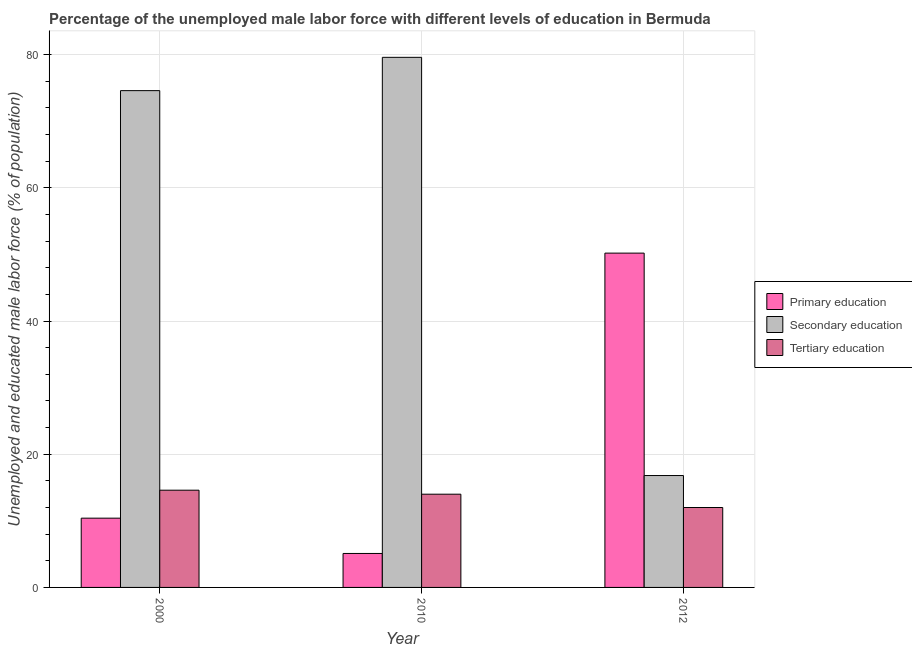How many bars are there on the 2nd tick from the left?
Offer a terse response. 3. What is the label of the 2nd group of bars from the left?
Keep it short and to the point. 2010. In how many cases, is the number of bars for a given year not equal to the number of legend labels?
Your answer should be compact. 0. What is the percentage of male labor force who received tertiary education in 2012?
Your answer should be compact. 12. Across all years, what is the maximum percentage of male labor force who received secondary education?
Give a very brief answer. 79.6. Across all years, what is the minimum percentage of male labor force who received primary education?
Keep it short and to the point. 5.1. In which year was the percentage of male labor force who received primary education maximum?
Offer a terse response. 2012. In which year was the percentage of male labor force who received primary education minimum?
Ensure brevity in your answer.  2010. What is the total percentage of male labor force who received secondary education in the graph?
Your answer should be compact. 171. What is the difference between the percentage of male labor force who received primary education in 2000 and that in 2010?
Give a very brief answer. 5.3. What is the difference between the percentage of male labor force who received secondary education in 2010 and the percentage of male labor force who received tertiary education in 2012?
Provide a succinct answer. 62.8. What is the average percentage of male labor force who received secondary education per year?
Your answer should be compact. 57. In how many years, is the percentage of male labor force who received tertiary education greater than 4 %?
Keep it short and to the point. 3. What is the ratio of the percentage of male labor force who received secondary education in 2000 to that in 2012?
Provide a short and direct response. 4.44. What is the difference between the highest and the second highest percentage of male labor force who received primary education?
Ensure brevity in your answer.  39.8. What is the difference between the highest and the lowest percentage of male labor force who received secondary education?
Your response must be concise. 62.8. What does the 3rd bar from the left in 2000 represents?
Your response must be concise. Tertiary education. Is it the case that in every year, the sum of the percentage of male labor force who received primary education and percentage of male labor force who received secondary education is greater than the percentage of male labor force who received tertiary education?
Give a very brief answer. Yes. How many bars are there?
Ensure brevity in your answer.  9. Are all the bars in the graph horizontal?
Make the answer very short. No. What is the difference between two consecutive major ticks on the Y-axis?
Keep it short and to the point. 20. Does the graph contain grids?
Your answer should be very brief. Yes. Where does the legend appear in the graph?
Offer a very short reply. Center right. How many legend labels are there?
Keep it short and to the point. 3. What is the title of the graph?
Provide a short and direct response. Percentage of the unemployed male labor force with different levels of education in Bermuda. What is the label or title of the Y-axis?
Offer a terse response. Unemployed and educated male labor force (% of population). What is the Unemployed and educated male labor force (% of population) in Primary education in 2000?
Your response must be concise. 10.4. What is the Unemployed and educated male labor force (% of population) of Secondary education in 2000?
Provide a short and direct response. 74.6. What is the Unemployed and educated male labor force (% of population) of Tertiary education in 2000?
Give a very brief answer. 14.6. What is the Unemployed and educated male labor force (% of population) of Primary education in 2010?
Your answer should be very brief. 5.1. What is the Unemployed and educated male labor force (% of population) in Secondary education in 2010?
Provide a short and direct response. 79.6. What is the Unemployed and educated male labor force (% of population) in Tertiary education in 2010?
Ensure brevity in your answer.  14. What is the Unemployed and educated male labor force (% of population) in Primary education in 2012?
Offer a very short reply. 50.2. What is the Unemployed and educated male labor force (% of population) in Secondary education in 2012?
Make the answer very short. 16.8. What is the Unemployed and educated male labor force (% of population) in Tertiary education in 2012?
Your answer should be very brief. 12. Across all years, what is the maximum Unemployed and educated male labor force (% of population) in Primary education?
Your answer should be very brief. 50.2. Across all years, what is the maximum Unemployed and educated male labor force (% of population) in Secondary education?
Provide a short and direct response. 79.6. Across all years, what is the maximum Unemployed and educated male labor force (% of population) of Tertiary education?
Your answer should be compact. 14.6. Across all years, what is the minimum Unemployed and educated male labor force (% of population) of Primary education?
Ensure brevity in your answer.  5.1. Across all years, what is the minimum Unemployed and educated male labor force (% of population) of Secondary education?
Your answer should be compact. 16.8. What is the total Unemployed and educated male labor force (% of population) in Primary education in the graph?
Make the answer very short. 65.7. What is the total Unemployed and educated male labor force (% of population) of Secondary education in the graph?
Give a very brief answer. 171. What is the total Unemployed and educated male labor force (% of population) of Tertiary education in the graph?
Your answer should be very brief. 40.6. What is the difference between the Unemployed and educated male labor force (% of population) in Secondary education in 2000 and that in 2010?
Make the answer very short. -5. What is the difference between the Unemployed and educated male labor force (% of population) in Primary education in 2000 and that in 2012?
Make the answer very short. -39.8. What is the difference between the Unemployed and educated male labor force (% of population) of Secondary education in 2000 and that in 2012?
Ensure brevity in your answer.  57.8. What is the difference between the Unemployed and educated male labor force (% of population) of Tertiary education in 2000 and that in 2012?
Provide a succinct answer. 2.6. What is the difference between the Unemployed and educated male labor force (% of population) in Primary education in 2010 and that in 2012?
Give a very brief answer. -45.1. What is the difference between the Unemployed and educated male labor force (% of population) of Secondary education in 2010 and that in 2012?
Your answer should be compact. 62.8. What is the difference between the Unemployed and educated male labor force (% of population) in Primary education in 2000 and the Unemployed and educated male labor force (% of population) in Secondary education in 2010?
Keep it short and to the point. -69.2. What is the difference between the Unemployed and educated male labor force (% of population) in Primary education in 2000 and the Unemployed and educated male labor force (% of population) in Tertiary education in 2010?
Ensure brevity in your answer.  -3.6. What is the difference between the Unemployed and educated male labor force (% of population) in Secondary education in 2000 and the Unemployed and educated male labor force (% of population) in Tertiary education in 2010?
Offer a terse response. 60.6. What is the difference between the Unemployed and educated male labor force (% of population) of Primary education in 2000 and the Unemployed and educated male labor force (% of population) of Secondary education in 2012?
Offer a terse response. -6.4. What is the difference between the Unemployed and educated male labor force (% of population) in Secondary education in 2000 and the Unemployed and educated male labor force (% of population) in Tertiary education in 2012?
Your answer should be compact. 62.6. What is the difference between the Unemployed and educated male labor force (% of population) in Primary education in 2010 and the Unemployed and educated male labor force (% of population) in Secondary education in 2012?
Your answer should be very brief. -11.7. What is the difference between the Unemployed and educated male labor force (% of population) in Primary education in 2010 and the Unemployed and educated male labor force (% of population) in Tertiary education in 2012?
Your response must be concise. -6.9. What is the difference between the Unemployed and educated male labor force (% of population) of Secondary education in 2010 and the Unemployed and educated male labor force (% of population) of Tertiary education in 2012?
Offer a terse response. 67.6. What is the average Unemployed and educated male labor force (% of population) of Primary education per year?
Make the answer very short. 21.9. What is the average Unemployed and educated male labor force (% of population) of Tertiary education per year?
Provide a short and direct response. 13.53. In the year 2000, what is the difference between the Unemployed and educated male labor force (% of population) in Primary education and Unemployed and educated male labor force (% of population) in Secondary education?
Offer a terse response. -64.2. In the year 2000, what is the difference between the Unemployed and educated male labor force (% of population) in Primary education and Unemployed and educated male labor force (% of population) in Tertiary education?
Make the answer very short. -4.2. In the year 2010, what is the difference between the Unemployed and educated male labor force (% of population) of Primary education and Unemployed and educated male labor force (% of population) of Secondary education?
Your response must be concise. -74.5. In the year 2010, what is the difference between the Unemployed and educated male labor force (% of population) of Secondary education and Unemployed and educated male labor force (% of population) of Tertiary education?
Keep it short and to the point. 65.6. In the year 2012, what is the difference between the Unemployed and educated male labor force (% of population) of Primary education and Unemployed and educated male labor force (% of population) of Secondary education?
Give a very brief answer. 33.4. In the year 2012, what is the difference between the Unemployed and educated male labor force (% of population) of Primary education and Unemployed and educated male labor force (% of population) of Tertiary education?
Your answer should be very brief. 38.2. In the year 2012, what is the difference between the Unemployed and educated male labor force (% of population) of Secondary education and Unemployed and educated male labor force (% of population) of Tertiary education?
Your answer should be very brief. 4.8. What is the ratio of the Unemployed and educated male labor force (% of population) of Primary education in 2000 to that in 2010?
Provide a short and direct response. 2.04. What is the ratio of the Unemployed and educated male labor force (% of population) of Secondary education in 2000 to that in 2010?
Make the answer very short. 0.94. What is the ratio of the Unemployed and educated male labor force (% of population) of Tertiary education in 2000 to that in 2010?
Your response must be concise. 1.04. What is the ratio of the Unemployed and educated male labor force (% of population) of Primary education in 2000 to that in 2012?
Provide a succinct answer. 0.21. What is the ratio of the Unemployed and educated male labor force (% of population) of Secondary education in 2000 to that in 2012?
Provide a short and direct response. 4.44. What is the ratio of the Unemployed and educated male labor force (% of population) in Tertiary education in 2000 to that in 2012?
Provide a short and direct response. 1.22. What is the ratio of the Unemployed and educated male labor force (% of population) in Primary education in 2010 to that in 2012?
Keep it short and to the point. 0.1. What is the ratio of the Unemployed and educated male labor force (% of population) in Secondary education in 2010 to that in 2012?
Provide a short and direct response. 4.74. What is the difference between the highest and the second highest Unemployed and educated male labor force (% of population) in Primary education?
Your answer should be very brief. 39.8. What is the difference between the highest and the second highest Unemployed and educated male labor force (% of population) of Secondary education?
Keep it short and to the point. 5. What is the difference between the highest and the second highest Unemployed and educated male labor force (% of population) of Tertiary education?
Your answer should be compact. 0.6. What is the difference between the highest and the lowest Unemployed and educated male labor force (% of population) in Primary education?
Your answer should be compact. 45.1. What is the difference between the highest and the lowest Unemployed and educated male labor force (% of population) of Secondary education?
Your answer should be compact. 62.8. 